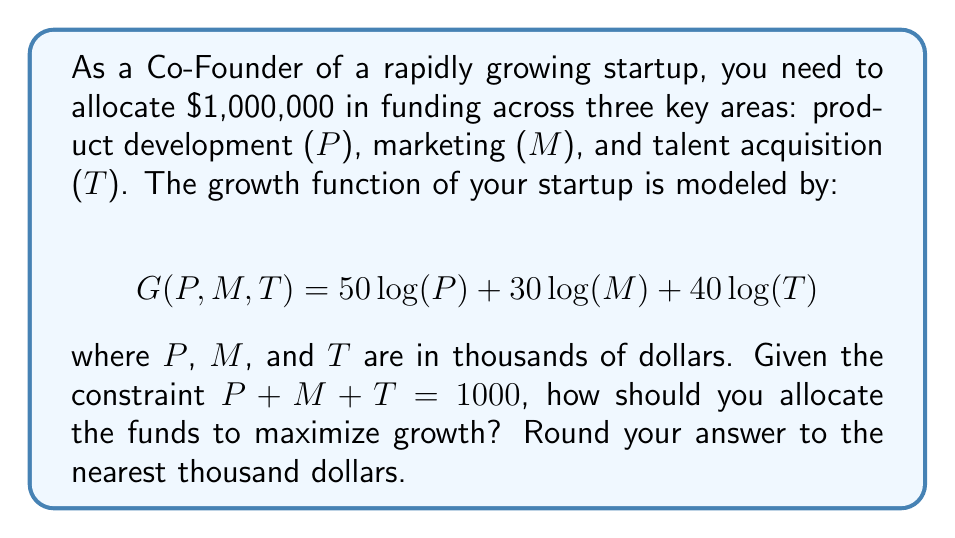Can you solve this math problem? To solve this optimization problem, we can use the method of Lagrange multipliers:

1) First, we set up the Lagrangian function:
   $$L(P,M,T,\lambda) = 50\log(P) + 30\log(M) + 40\log(T) - \lambda(P + M + T - 1000)$$

2) Now, we take partial derivatives and set them equal to zero:
   $$\frac{\partial L}{\partial P} = \frac{50}{P} - \lambda = 0$$
   $$\frac{\partial L}{\partial M} = \frac{30}{M} - \lambda = 0$$
   $$\frac{\partial L}{\partial T} = \frac{40}{T} - \lambda = 0$$
   $$\frac{\partial L}{\partial \lambda} = P + M + T - 1000 = 0$$

3) From the first three equations, we can derive:
   $$P = \frac{50}{\lambda}, M = \frac{30}{\lambda}, T = \frac{40}{\lambda}$$

4) Substituting these into the constraint equation:
   $$\frac{50}{\lambda} + \frac{30}{\lambda} + \frac{40}{\lambda} = 1000$$
   $$\frac{120}{\lambda} = 1000$$
   $$\lambda = \frac{120}{1000} = 0.12$$

5) Now we can solve for P, M, and T:
   $$P = \frac{50}{0.12} = 416.67$$
   $$M = \frac{30}{0.12} = 250$$
   $$T = \frac{40}{0.12} = 333.33$$

6) Rounding to the nearest thousand:
   P ≈ 417,000
   M ≈ 250,000
   T ≈ 333,000
Answer: Allocate approximately $417,000 to product development, $250,000 to marketing, and $333,000 to talent acquisition. 